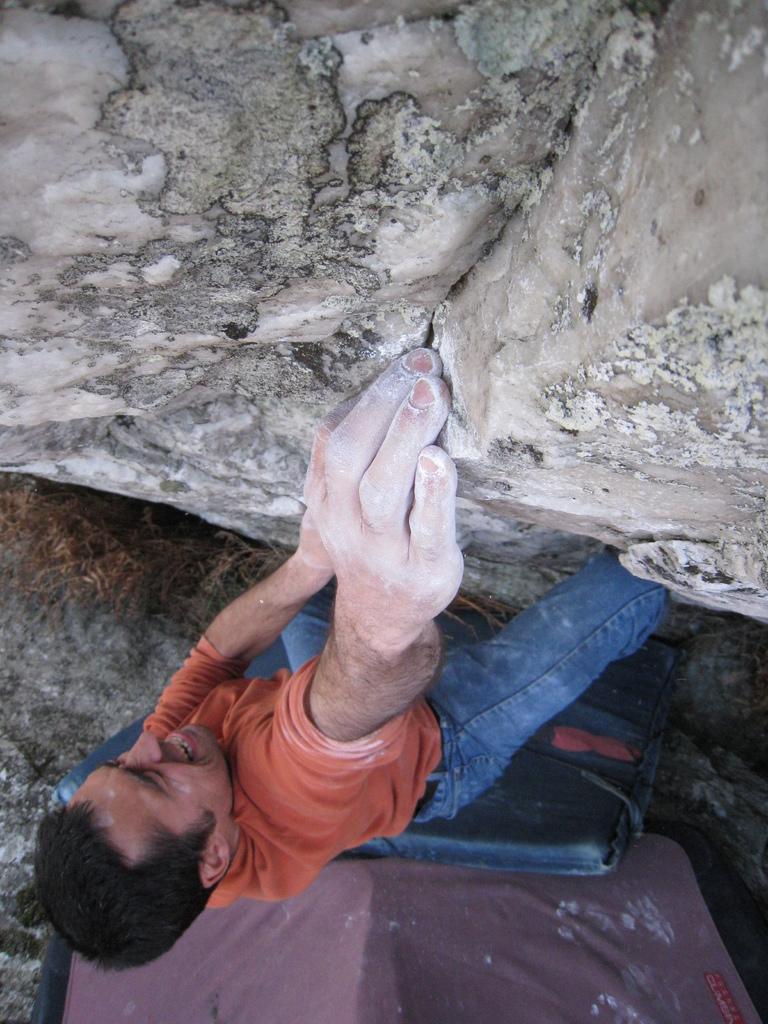Please provide a concise description of this image. In this picture we can see a man and looks like he is climbing a rock. At the bottom portion of the picture we can see objects and a rock. 